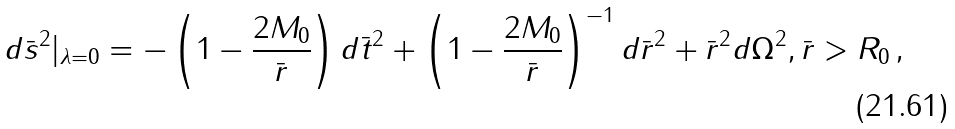<formula> <loc_0><loc_0><loc_500><loc_500>d \bar { s } ^ { 2 } | _ { \lambda = 0 } = - \left ( 1 - \frac { 2 M _ { 0 } } { \bar { r } } \right ) d \bar { t } ^ { 2 } + \left ( 1 - \frac { 2 M _ { 0 } } { \bar { r } } \right ) ^ { - 1 } d \bar { r } ^ { 2 } + \bar { r } ^ { 2 } d \Omega ^ { 2 } , \bar { r } > R _ { 0 } \, ,</formula> 